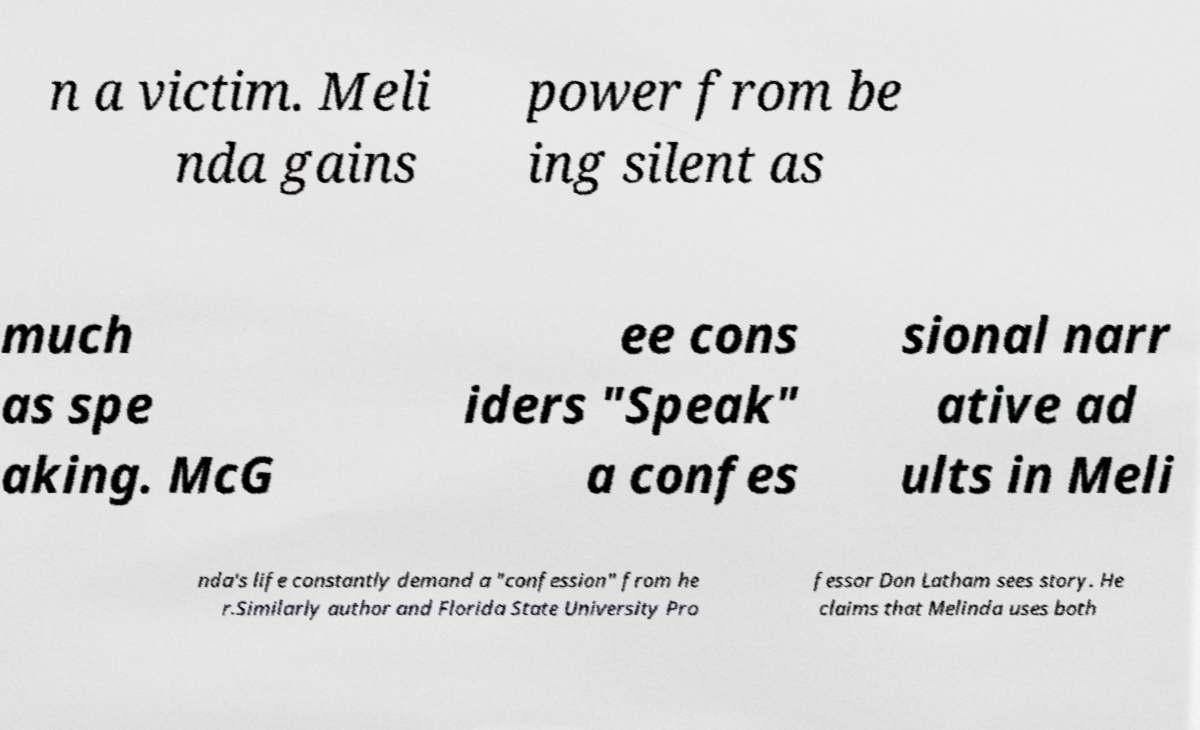Could you assist in decoding the text presented in this image and type it out clearly? n a victim. Meli nda gains power from be ing silent as much as spe aking. McG ee cons iders "Speak" a confes sional narr ative ad ults in Meli nda's life constantly demand a "confession" from he r.Similarly author and Florida State University Pro fessor Don Latham sees story. He claims that Melinda uses both 